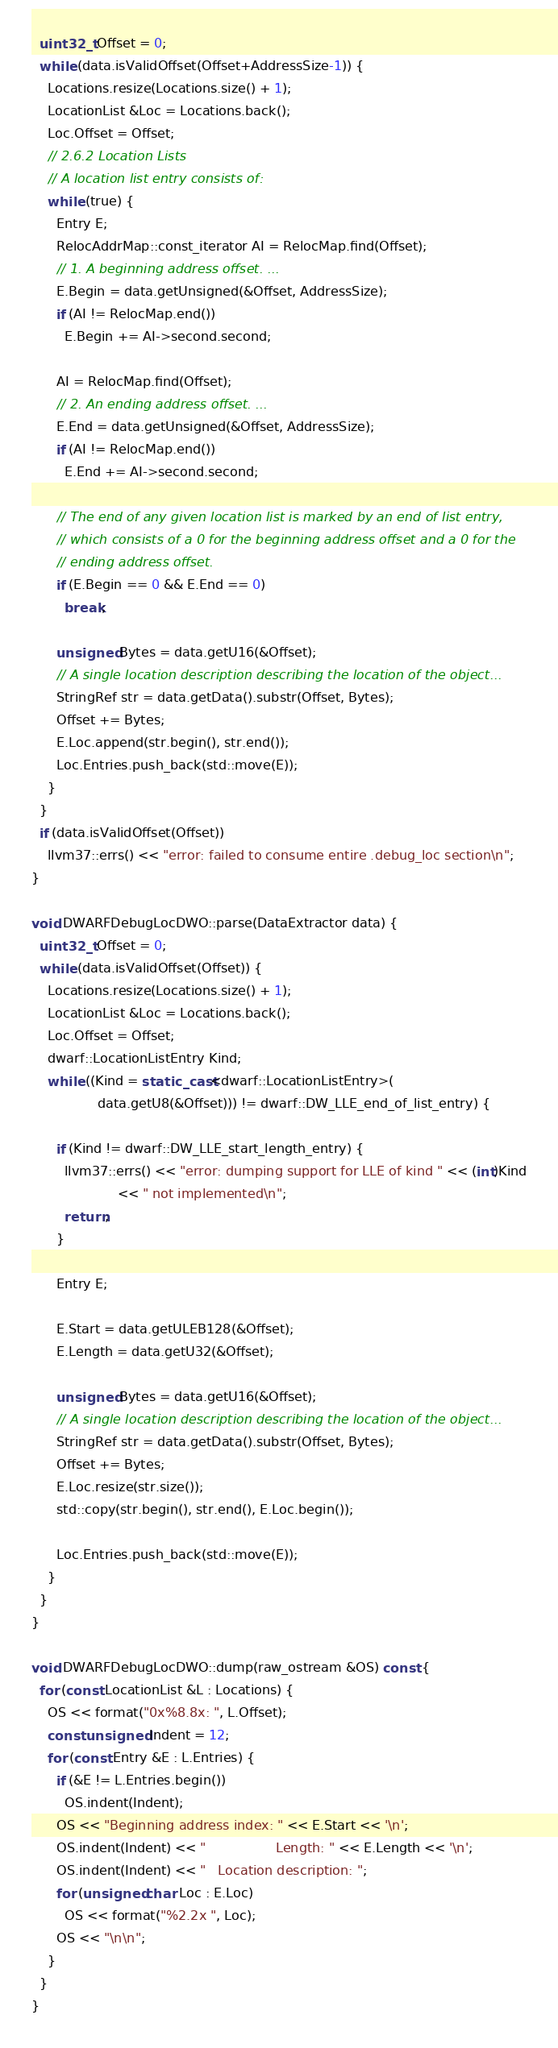Convert code to text. <code><loc_0><loc_0><loc_500><loc_500><_C++_>  uint32_t Offset = 0;
  while (data.isValidOffset(Offset+AddressSize-1)) {
    Locations.resize(Locations.size() + 1);
    LocationList &Loc = Locations.back();
    Loc.Offset = Offset;
    // 2.6.2 Location Lists
    // A location list entry consists of:
    while (true) {
      Entry E;
      RelocAddrMap::const_iterator AI = RelocMap.find(Offset);
      // 1. A beginning address offset. ...
      E.Begin = data.getUnsigned(&Offset, AddressSize);
      if (AI != RelocMap.end())
        E.Begin += AI->second.second;

      AI = RelocMap.find(Offset);
      // 2. An ending address offset. ...
      E.End = data.getUnsigned(&Offset, AddressSize);
      if (AI != RelocMap.end())
        E.End += AI->second.second;

      // The end of any given location list is marked by an end of list entry,
      // which consists of a 0 for the beginning address offset and a 0 for the
      // ending address offset.
      if (E.Begin == 0 && E.End == 0)
        break;

      unsigned Bytes = data.getU16(&Offset);
      // A single location description describing the location of the object...
      StringRef str = data.getData().substr(Offset, Bytes);
      Offset += Bytes;
      E.Loc.append(str.begin(), str.end());
      Loc.Entries.push_back(std::move(E));
    }
  }
  if (data.isValidOffset(Offset))
    llvm37::errs() << "error: failed to consume entire .debug_loc section\n";
}

void DWARFDebugLocDWO::parse(DataExtractor data) {
  uint32_t Offset = 0;
  while (data.isValidOffset(Offset)) {
    Locations.resize(Locations.size() + 1);
    LocationList &Loc = Locations.back();
    Loc.Offset = Offset;
    dwarf::LocationListEntry Kind;
    while ((Kind = static_cast<dwarf::LocationListEntry>(
                data.getU8(&Offset))) != dwarf::DW_LLE_end_of_list_entry) {

      if (Kind != dwarf::DW_LLE_start_length_entry) {
        llvm37::errs() << "error: dumping support for LLE of kind " << (int)Kind
                     << " not implemented\n";
        return;
      }

      Entry E;

      E.Start = data.getULEB128(&Offset);
      E.Length = data.getU32(&Offset);

      unsigned Bytes = data.getU16(&Offset);
      // A single location description describing the location of the object...
      StringRef str = data.getData().substr(Offset, Bytes);
      Offset += Bytes;
      E.Loc.resize(str.size());
      std::copy(str.begin(), str.end(), E.Loc.begin());

      Loc.Entries.push_back(std::move(E));
    }
  }
}

void DWARFDebugLocDWO::dump(raw_ostream &OS) const {
  for (const LocationList &L : Locations) {
    OS << format("0x%8.8x: ", L.Offset);
    const unsigned Indent = 12;
    for (const Entry &E : L.Entries) {
      if (&E != L.Entries.begin())
        OS.indent(Indent);
      OS << "Beginning address index: " << E.Start << '\n';
      OS.indent(Indent) << "                 Length: " << E.Length << '\n';
      OS.indent(Indent) << "   Location description: ";
      for (unsigned char Loc : E.Loc)
        OS << format("%2.2x ", Loc);
      OS << "\n\n";
    }
  }
}

</code> 